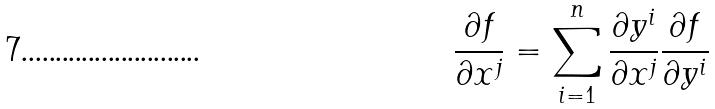Convert formula to latex. <formula><loc_0><loc_0><loc_500><loc_500>\frac { \partial f } { \partial x ^ { j } } = \sum _ { i = 1 } ^ { n } \frac { \partial y ^ { i } } { \partial x ^ { j } } \frac { \partial f } { \partial y ^ { i } }</formula> 